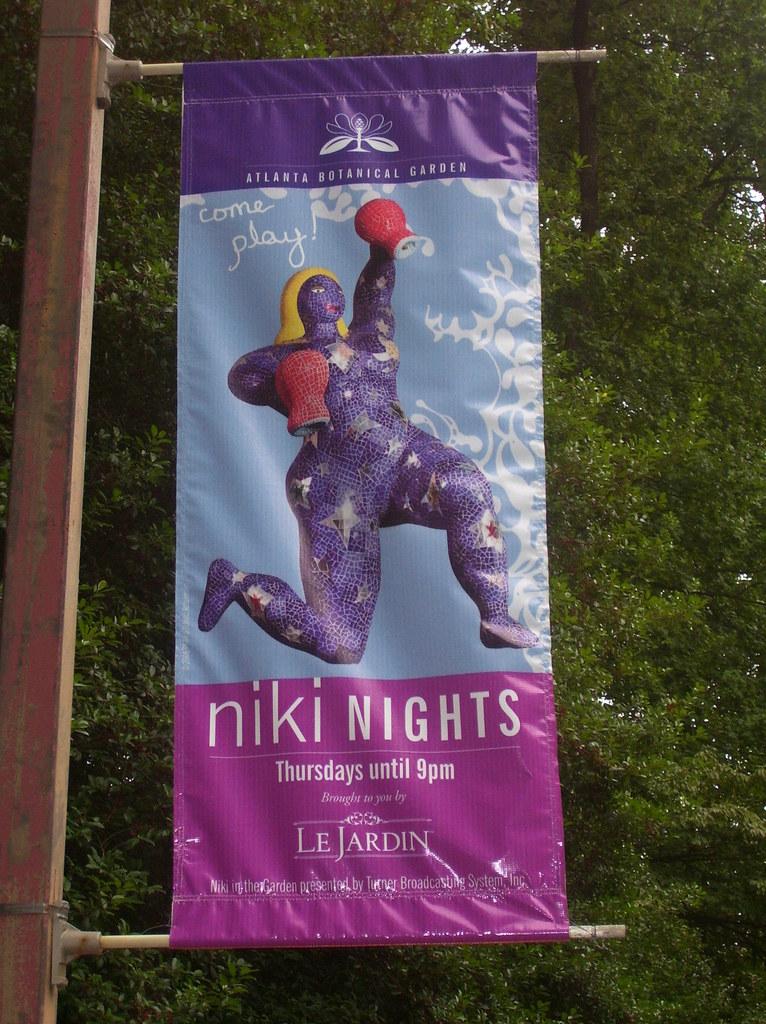When are niki nights open?
Keep it short and to the point. Thursdays. 